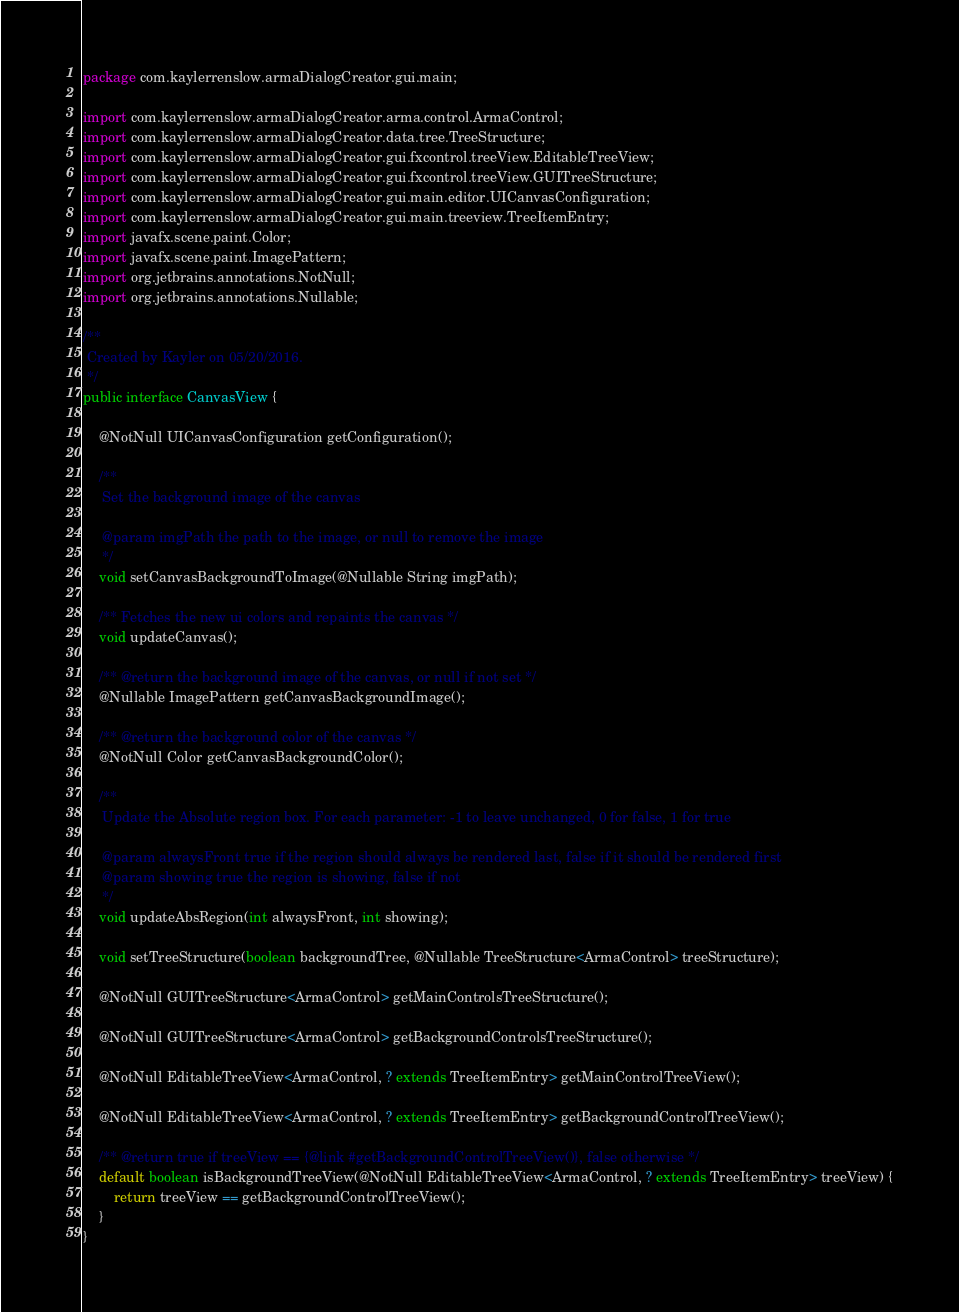<code> <loc_0><loc_0><loc_500><loc_500><_Java_>package com.kaylerrenslow.armaDialogCreator.gui.main;

import com.kaylerrenslow.armaDialogCreator.arma.control.ArmaControl;
import com.kaylerrenslow.armaDialogCreator.data.tree.TreeStructure;
import com.kaylerrenslow.armaDialogCreator.gui.fxcontrol.treeView.EditableTreeView;
import com.kaylerrenslow.armaDialogCreator.gui.fxcontrol.treeView.GUITreeStructure;
import com.kaylerrenslow.armaDialogCreator.gui.main.editor.UICanvasConfiguration;
import com.kaylerrenslow.armaDialogCreator.gui.main.treeview.TreeItemEntry;
import javafx.scene.paint.Color;
import javafx.scene.paint.ImagePattern;
import org.jetbrains.annotations.NotNull;
import org.jetbrains.annotations.Nullable;

/**
 Created by Kayler on 05/20/2016.
 */
public interface CanvasView {

	@NotNull UICanvasConfiguration getConfiguration();

	/**
	 Set the background image of the canvas

	 @param imgPath the path to the image, or null to remove the image
	 */
	void setCanvasBackgroundToImage(@Nullable String imgPath);

	/** Fetches the new ui colors and repaints the canvas */
	void updateCanvas();

	/** @return the background image of the canvas, or null if not set */
	@Nullable ImagePattern getCanvasBackgroundImage();

	/** @return the background color of the canvas */
	@NotNull Color getCanvasBackgroundColor();

	/**
	 Update the Absolute region box. For each parameter: -1 to leave unchanged, 0 for false, 1 for true

	 @param alwaysFront true if the region should always be rendered last, false if it should be rendered first
	 @param showing true the region is showing, false if not
	 */
	void updateAbsRegion(int alwaysFront, int showing);

	void setTreeStructure(boolean backgroundTree, @Nullable TreeStructure<ArmaControl> treeStructure);

	@NotNull GUITreeStructure<ArmaControl> getMainControlsTreeStructure();

	@NotNull GUITreeStructure<ArmaControl> getBackgroundControlsTreeStructure();

	@NotNull EditableTreeView<ArmaControl, ? extends TreeItemEntry> getMainControlTreeView();

	@NotNull EditableTreeView<ArmaControl, ? extends TreeItemEntry> getBackgroundControlTreeView();

	/** @return true if treeView == {@link #getBackgroundControlTreeView()}, false otherwise */
	default boolean isBackgroundTreeView(@NotNull EditableTreeView<ArmaControl, ? extends TreeItemEntry> treeView) {
		return treeView == getBackgroundControlTreeView();
	}
}
</code> 